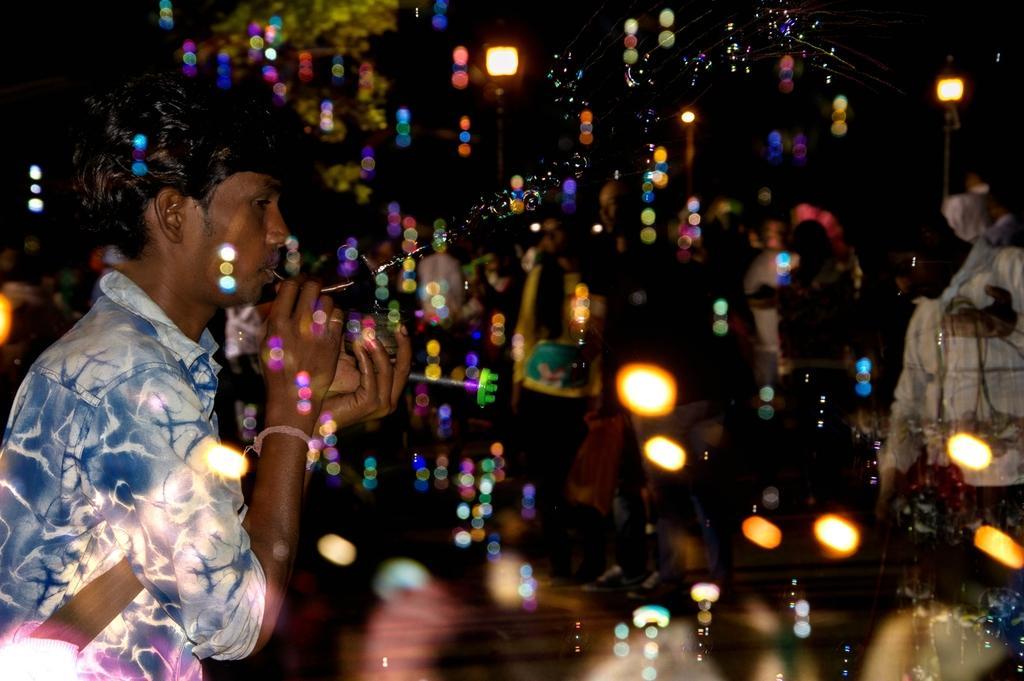Describe this image in one or two sentences. In the image we can see a man wearing clothes and holding an object in his mouth. Here we can see foam bubbles, light and the back is dark blurred. 